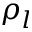Convert formula to latex. <formula><loc_0><loc_0><loc_500><loc_500>\rho _ { l }</formula> 